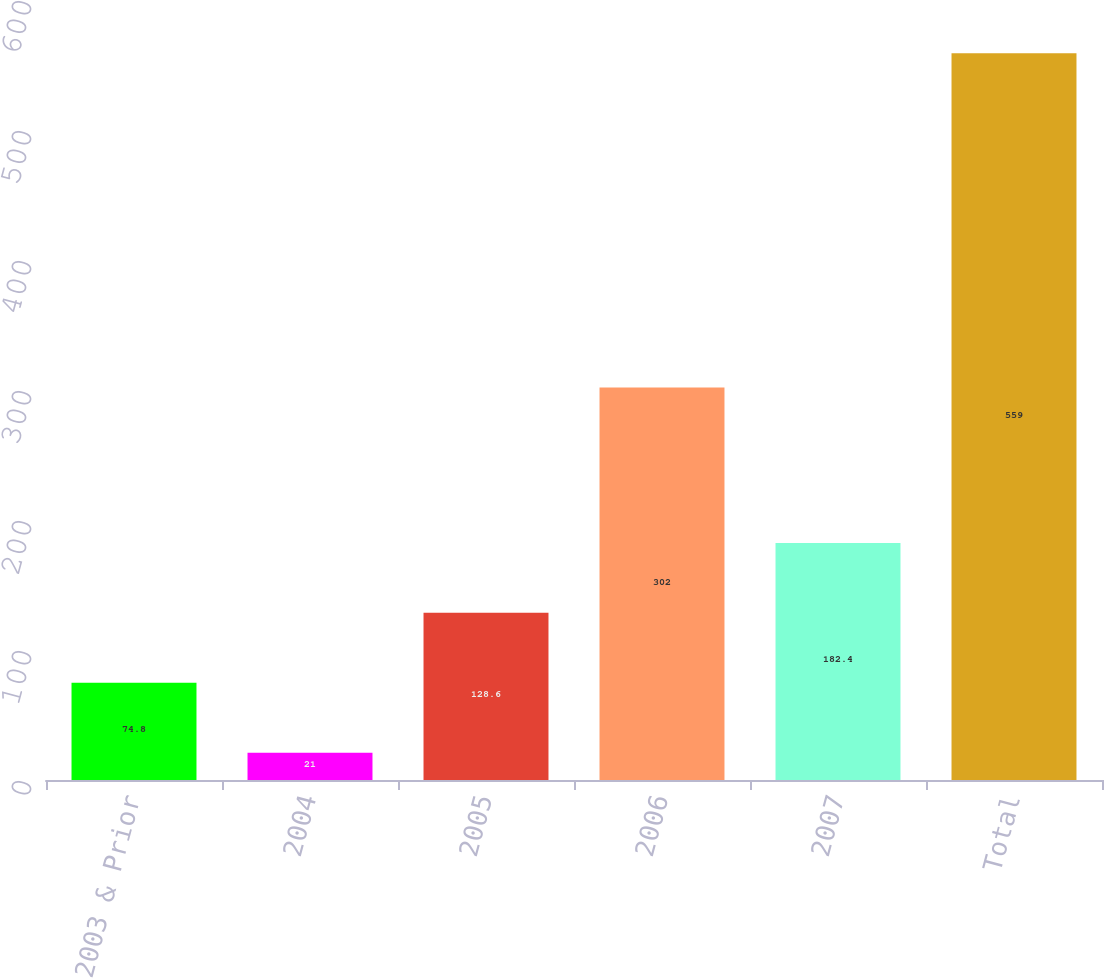Convert chart. <chart><loc_0><loc_0><loc_500><loc_500><bar_chart><fcel>2003 & Prior<fcel>2004<fcel>2005<fcel>2006<fcel>2007<fcel>Total<nl><fcel>74.8<fcel>21<fcel>128.6<fcel>302<fcel>182.4<fcel>559<nl></chart> 